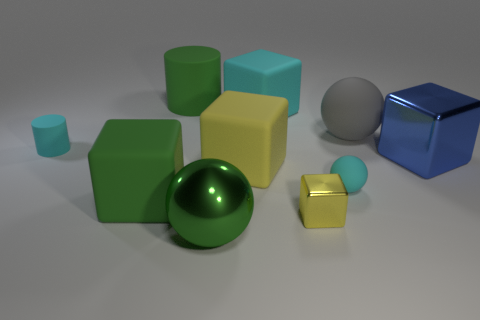Subtract all blue blocks. How many blocks are left? 4 Subtract all cyan rubber blocks. How many blocks are left? 4 Subtract all gray blocks. Subtract all cyan cylinders. How many blocks are left? 5 Subtract all balls. How many objects are left? 7 Subtract 1 gray spheres. How many objects are left? 9 Subtract all small red rubber cylinders. Subtract all big yellow objects. How many objects are left? 9 Add 2 large green rubber objects. How many large green rubber objects are left? 4 Add 1 small yellow cubes. How many small yellow cubes exist? 2 